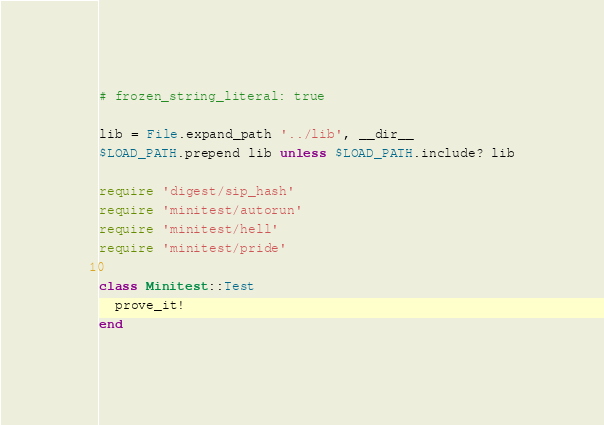Convert code to text. <code><loc_0><loc_0><loc_500><loc_500><_Ruby_># frozen_string_literal: true

lib = File.expand_path '../lib', __dir__
$LOAD_PATH.prepend lib unless $LOAD_PATH.include? lib

require 'digest/sip_hash'
require 'minitest/autorun'
require 'minitest/hell'
require 'minitest/pride'

class Minitest::Test
  prove_it!
end
</code> 